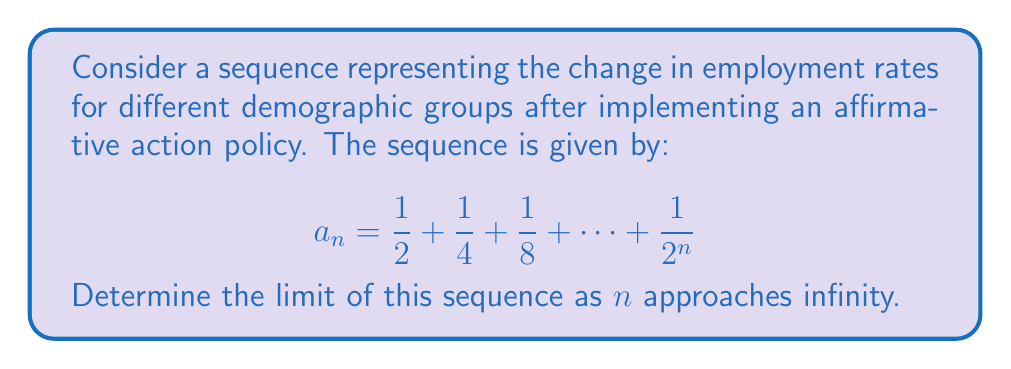Show me your answer to this math problem. To find the limit of this sequence, we can follow these steps:

1) First, recognize that this is a geometric series with first term $a = \frac{1}{2}$ and common ratio $r = \frac{1}{2}$.

2) The sum of a geometric series with $n$ terms is given by the formula:

   $$S_n = \frac{a(1-r^n)}{1-r}$$

   where $a$ is the first term and $r$ is the common ratio.

3) In our case, $a = \frac{1}{2}$ and $r = \frac{1}{2}$. Substituting these values:

   $$a_n = S_n = \frac{\frac{1}{2}(1-(\frac{1}{2})^n)}{1-\frac{1}{2}} = \frac{\frac{1}{2}(1-\frac{1}{2^n})}{\frac{1}{2}} = 1 - \frac{1}{2^n}$$

4) To find the limit as $n$ approaches infinity:

   $$\lim_{n \to \infty} a_n = \lim_{n \to \infty} (1 - \frac{1}{2^n})$$

5) As $n$ approaches infinity, $\frac{1}{2^n}$ approaches 0, so:

   $$\lim_{n \to \infty} a_n = 1 - 0 = 1$$

Therefore, the limit of the sequence as $n$ approaches infinity is 1.
Answer: $1$ 